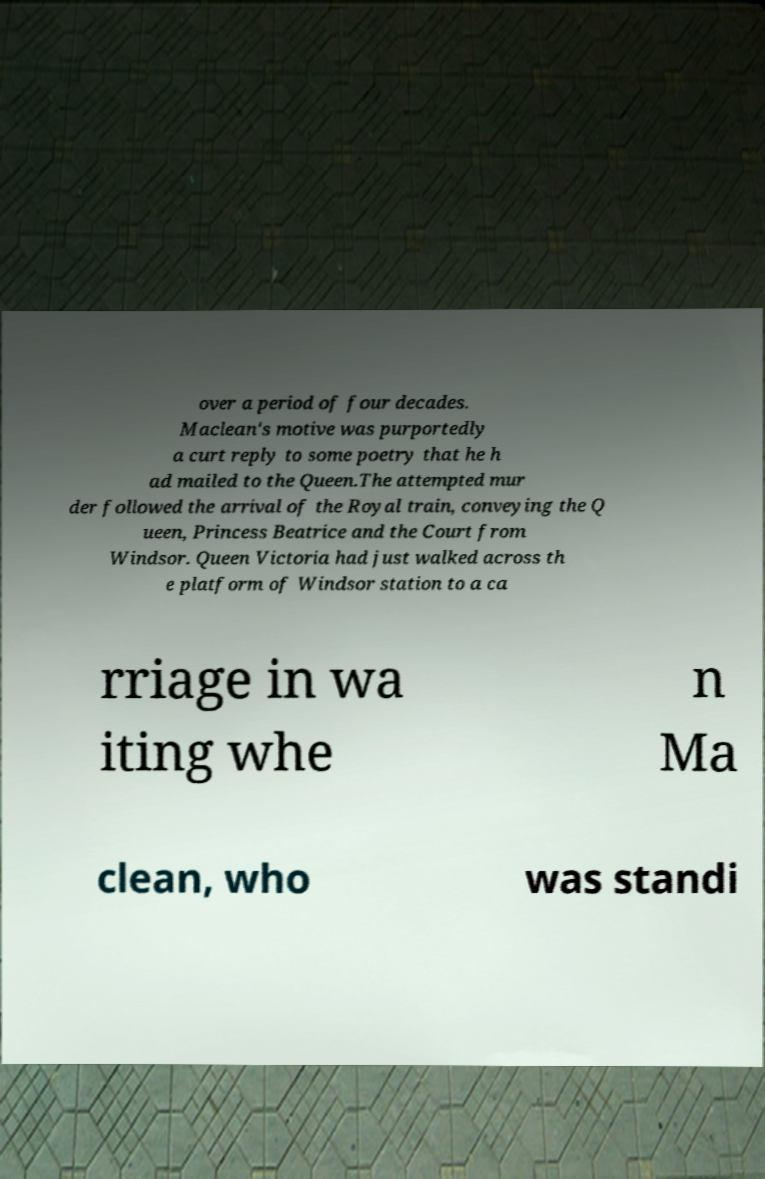Could you assist in decoding the text presented in this image and type it out clearly? over a period of four decades. Maclean's motive was purportedly a curt reply to some poetry that he h ad mailed to the Queen.The attempted mur der followed the arrival of the Royal train, conveying the Q ueen, Princess Beatrice and the Court from Windsor. Queen Victoria had just walked across th e platform of Windsor station to a ca rriage in wa iting whe n Ma clean, who was standi 